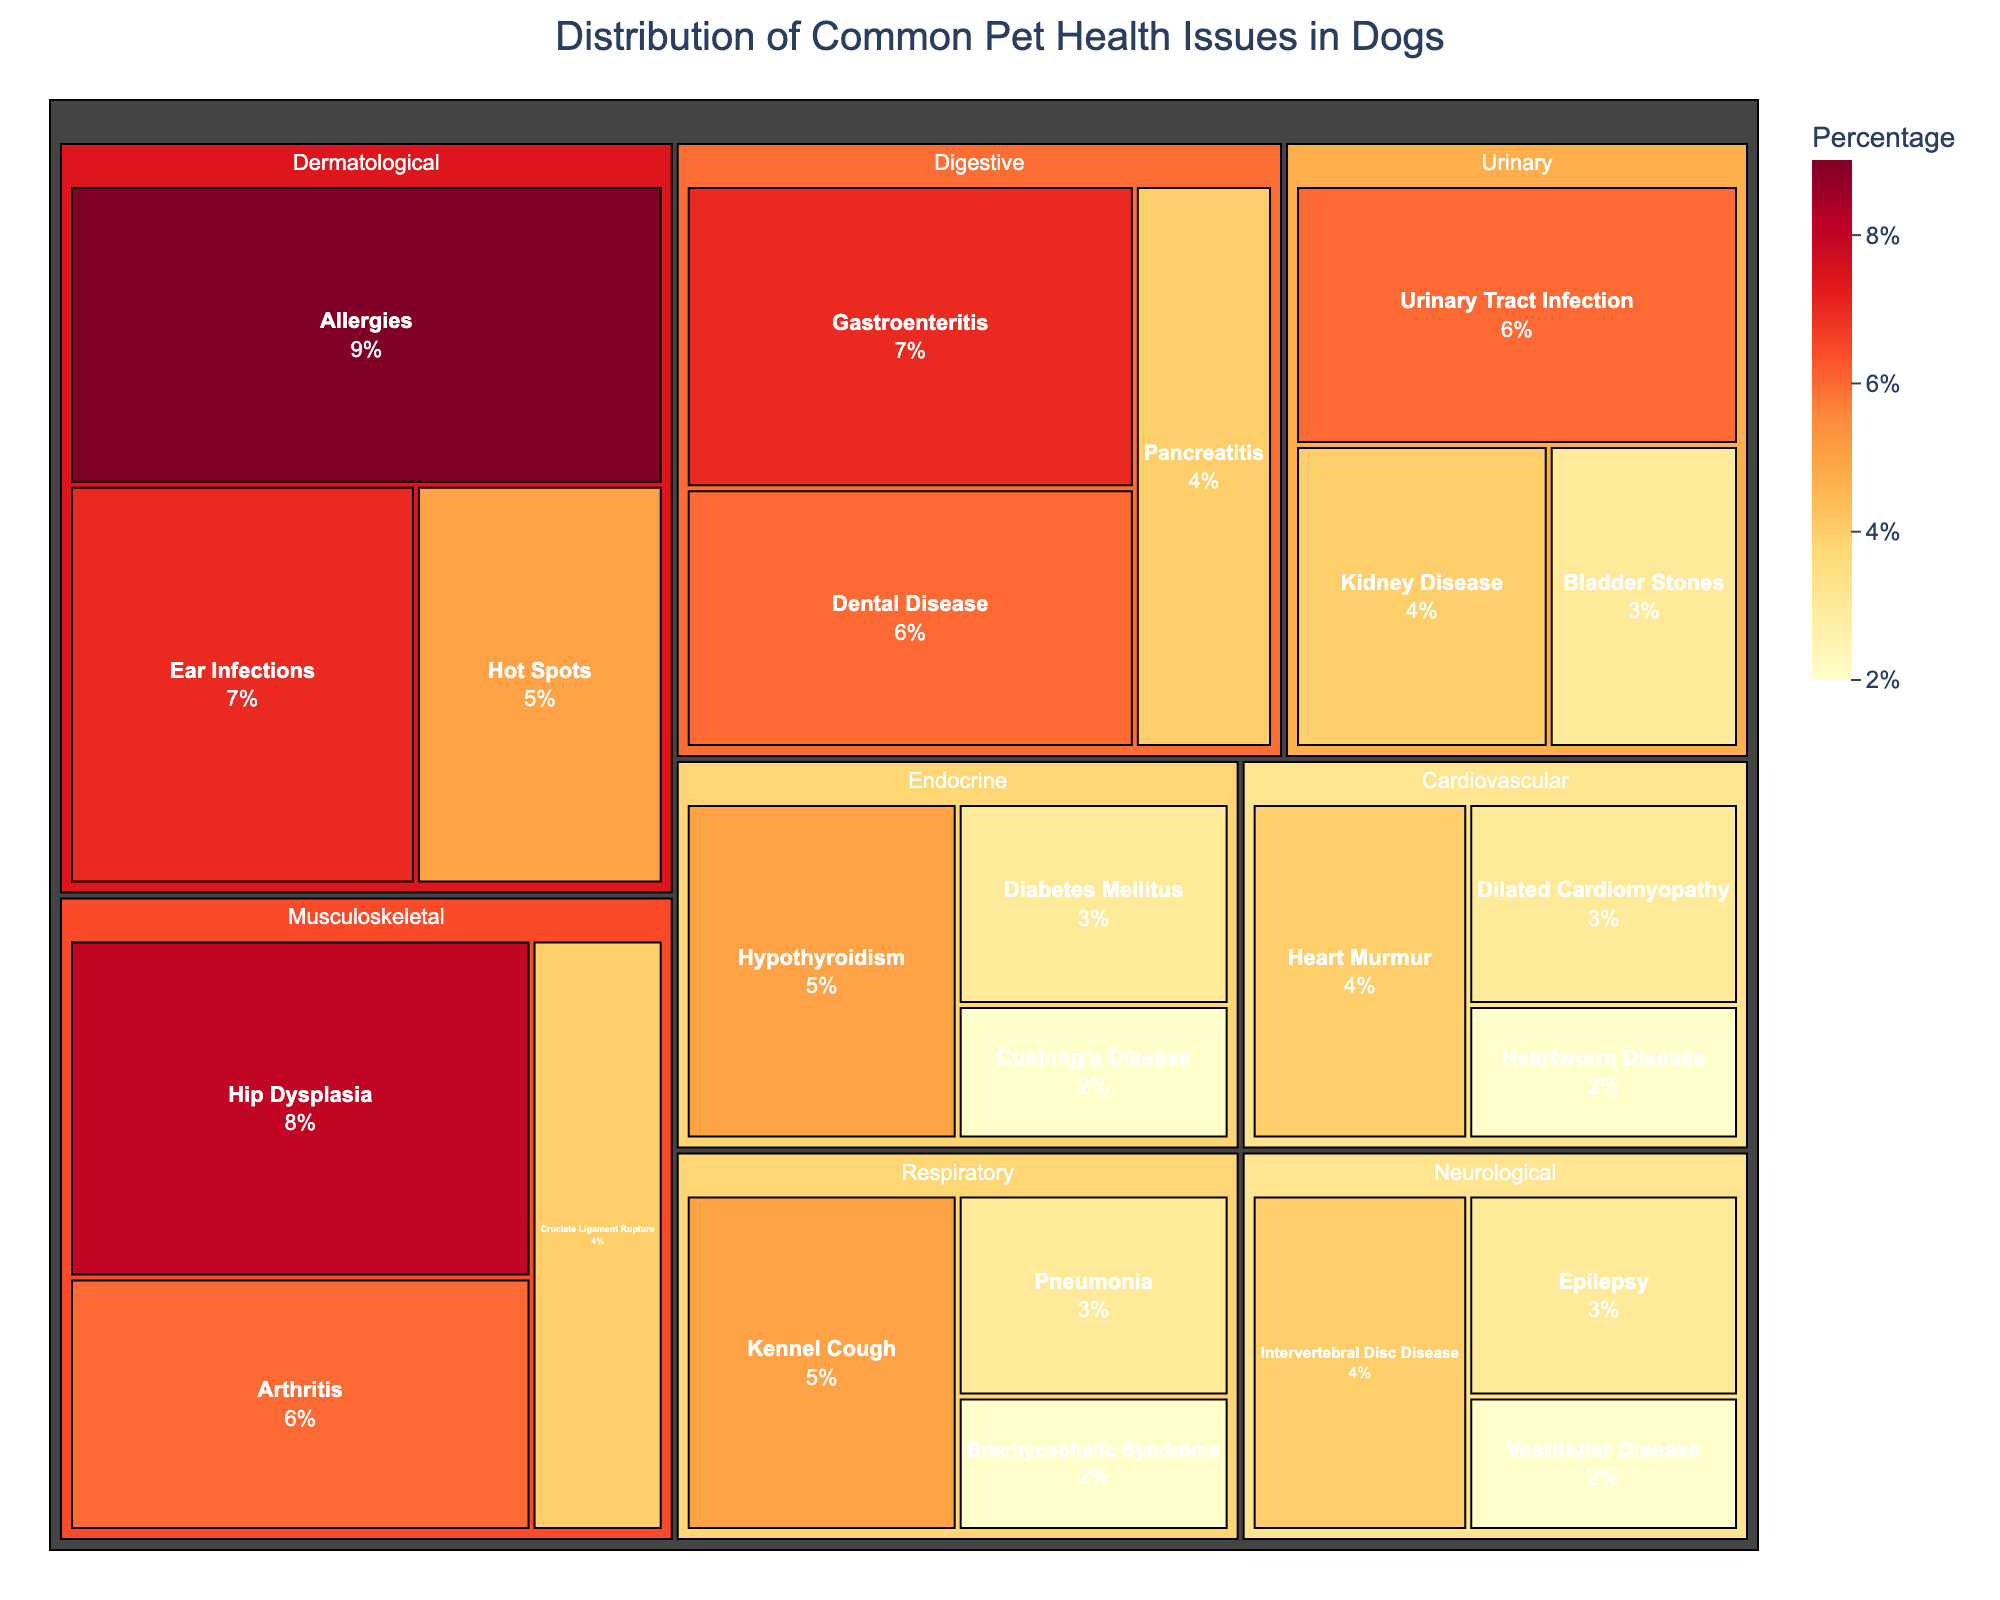What is the title of the treemap? The title of the treemap is usually located at the top of the figure. In this case, it clearly states the focus of the data being represented.
Answer: Distribution of Common Pet Health Issues in Dogs Which category under the 'Musculoskeletal' system has the highest percentage? We see the different categories under the 'Musculoskeletal' system along with their respective percentages: Hip Dysplasia (8%), Arthritis (6%), and Cruciate Ligament Rupture (4%). The highest percentage among them is 8% for Hip Dysplasia.
Answer: Hip Dysplasia Which body system has the most number of categories listed? By counting the categories listed under each body system, we can see that the 'Neurological' and the 'Respiratory' systems both have 3 categories each.
Answer: Neurological and Respiratory (tie) What is the combined percentage of common pet health issues in the 'Endocrine' system? The combined percentage is the sum of the percentages of Hypothyroidism (5%), Diabetes Mellitus (3%), and Cushing's Disease (2%). Adding them together, we get 5 + 3 + 2 = 10%.
Answer: 10% Comparing 'Digestive' and 'Dermatological' systems, which one has a higher total percentage and by how much? The total percentage for the 'Digestive' system is 7 + 4 + 6 = 17%. For the 'Dermatological' system, it's 9 + 5 + 7 = 21%. The difference between the two is 21 - 17 = 4%.
Answer: Dermatological system by 4% What percentage of pet health issues is represented by 'Respiratory' system if we disregard any other systems? The total percentage for Respiratory issues is calculated by adding Kennel Cough (5%), Pneumonia (3%), and Brachycephalic Syndrome (2%), which sums up to 10%.
Answer: 10% Which two categories under 'Neurological' system have the same percentages? The two categories under 'Neurological' system that have the same percentage are Intervertebral Disc Disease and Cruciate Ligament Rupture, both with 4%.
Answer: Intervertebral Disc Disease and Cruciate Ligament Rupture Which health issue has the highest percentage across all systems? By comparing all categories and their percentages, we find that the highest percentage is 9% for Allergies under the Dermatological system.
Answer: Allergies 